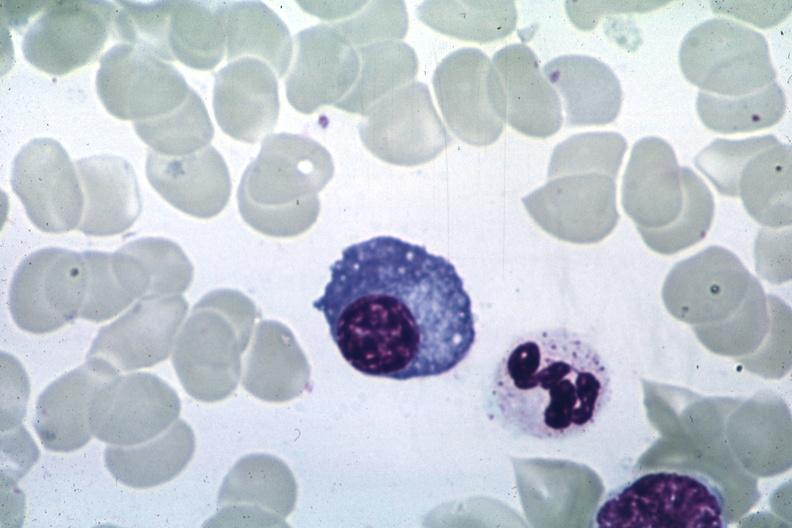does cephalohematoma show wrights?
Answer the question using a single word or phrase. No 